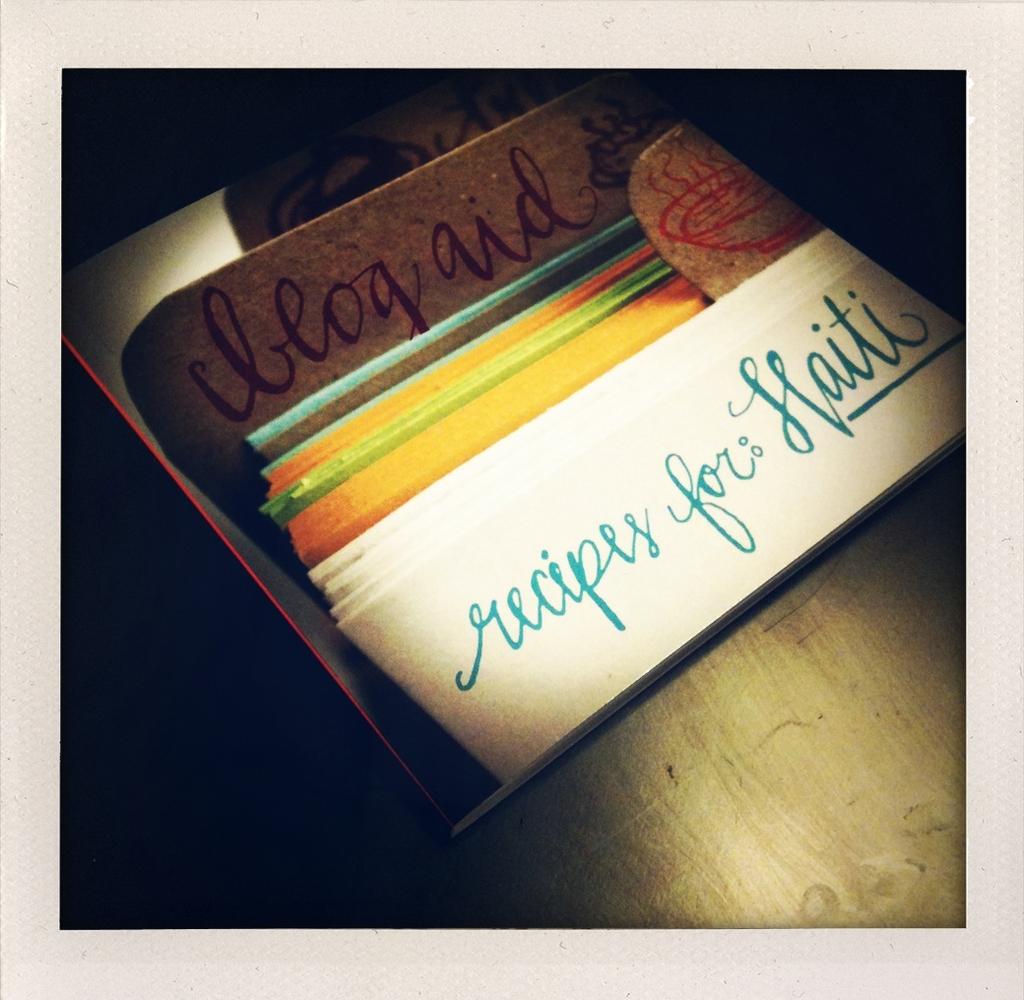Who are the recipes for in the folder?
Ensure brevity in your answer.  Haiti. What does it write in the top of the photo?
Make the answer very short. Blog aid. 